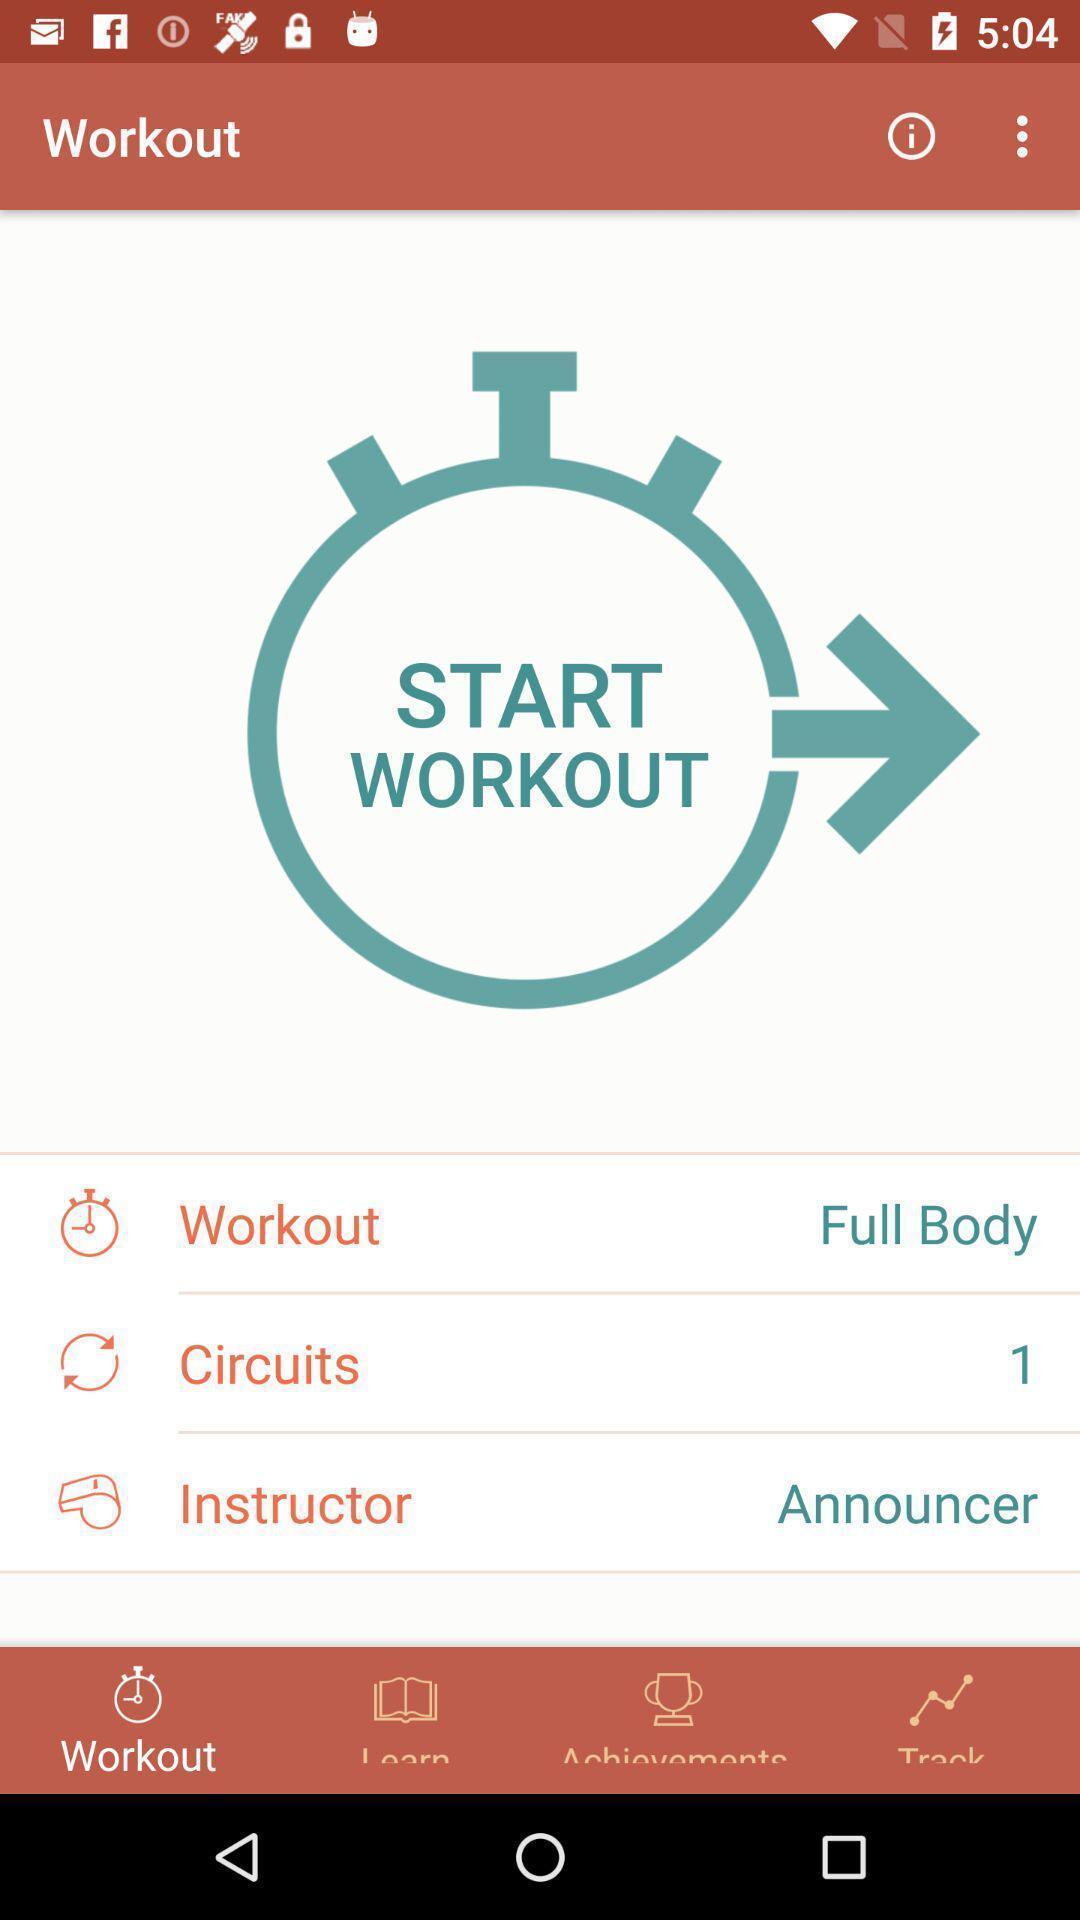Provide a description of this screenshot. Workout page displaying. 